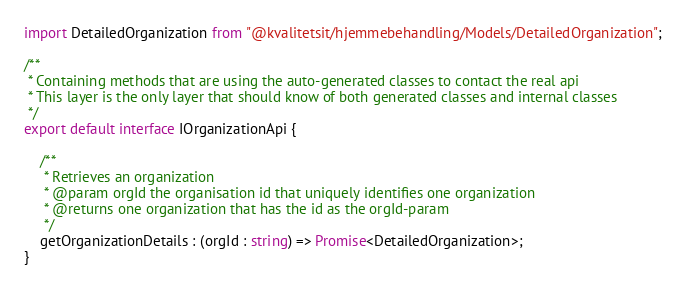Convert code to text. <code><loc_0><loc_0><loc_500><loc_500><_TypeScript_>import DetailedOrganization from "@kvalitetsit/hjemmebehandling/Models/DetailedOrganization";

/**
 * Containing methods that are using the auto-generated classes to contact the real api
 * This layer is the only layer that should know of both generated classes and internal classes
 */
export default interface IOrganizationApi {

    /**
     * Retrieves an organization
     * @param orgId the organisation id that uniquely identifies one organization
     * @returns one organization that has the id as the orgId-param
     */
    getOrganizationDetails : (orgId : string) => Promise<DetailedOrganization>;
}</code> 